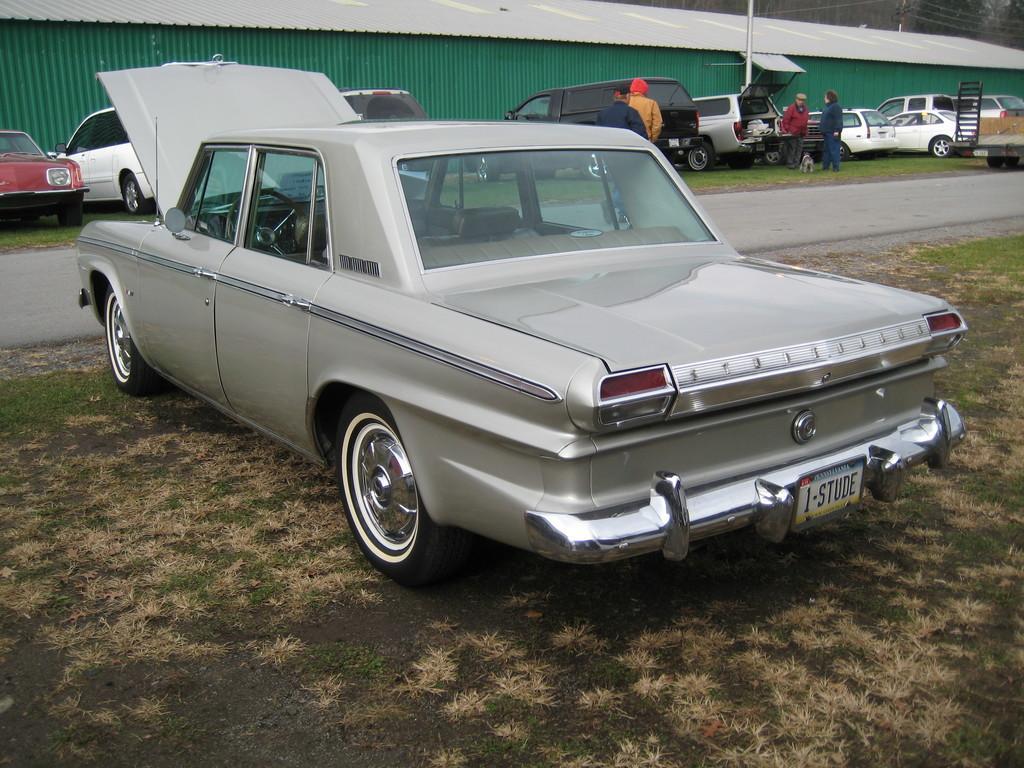Describe this image in one or two sentences. Here we can see a car on the grass on the ground. In the background we can see road, vehicles on the grass on the ground, few persons are standing, an animal, wall, roof, electric wires, pole and trees. 